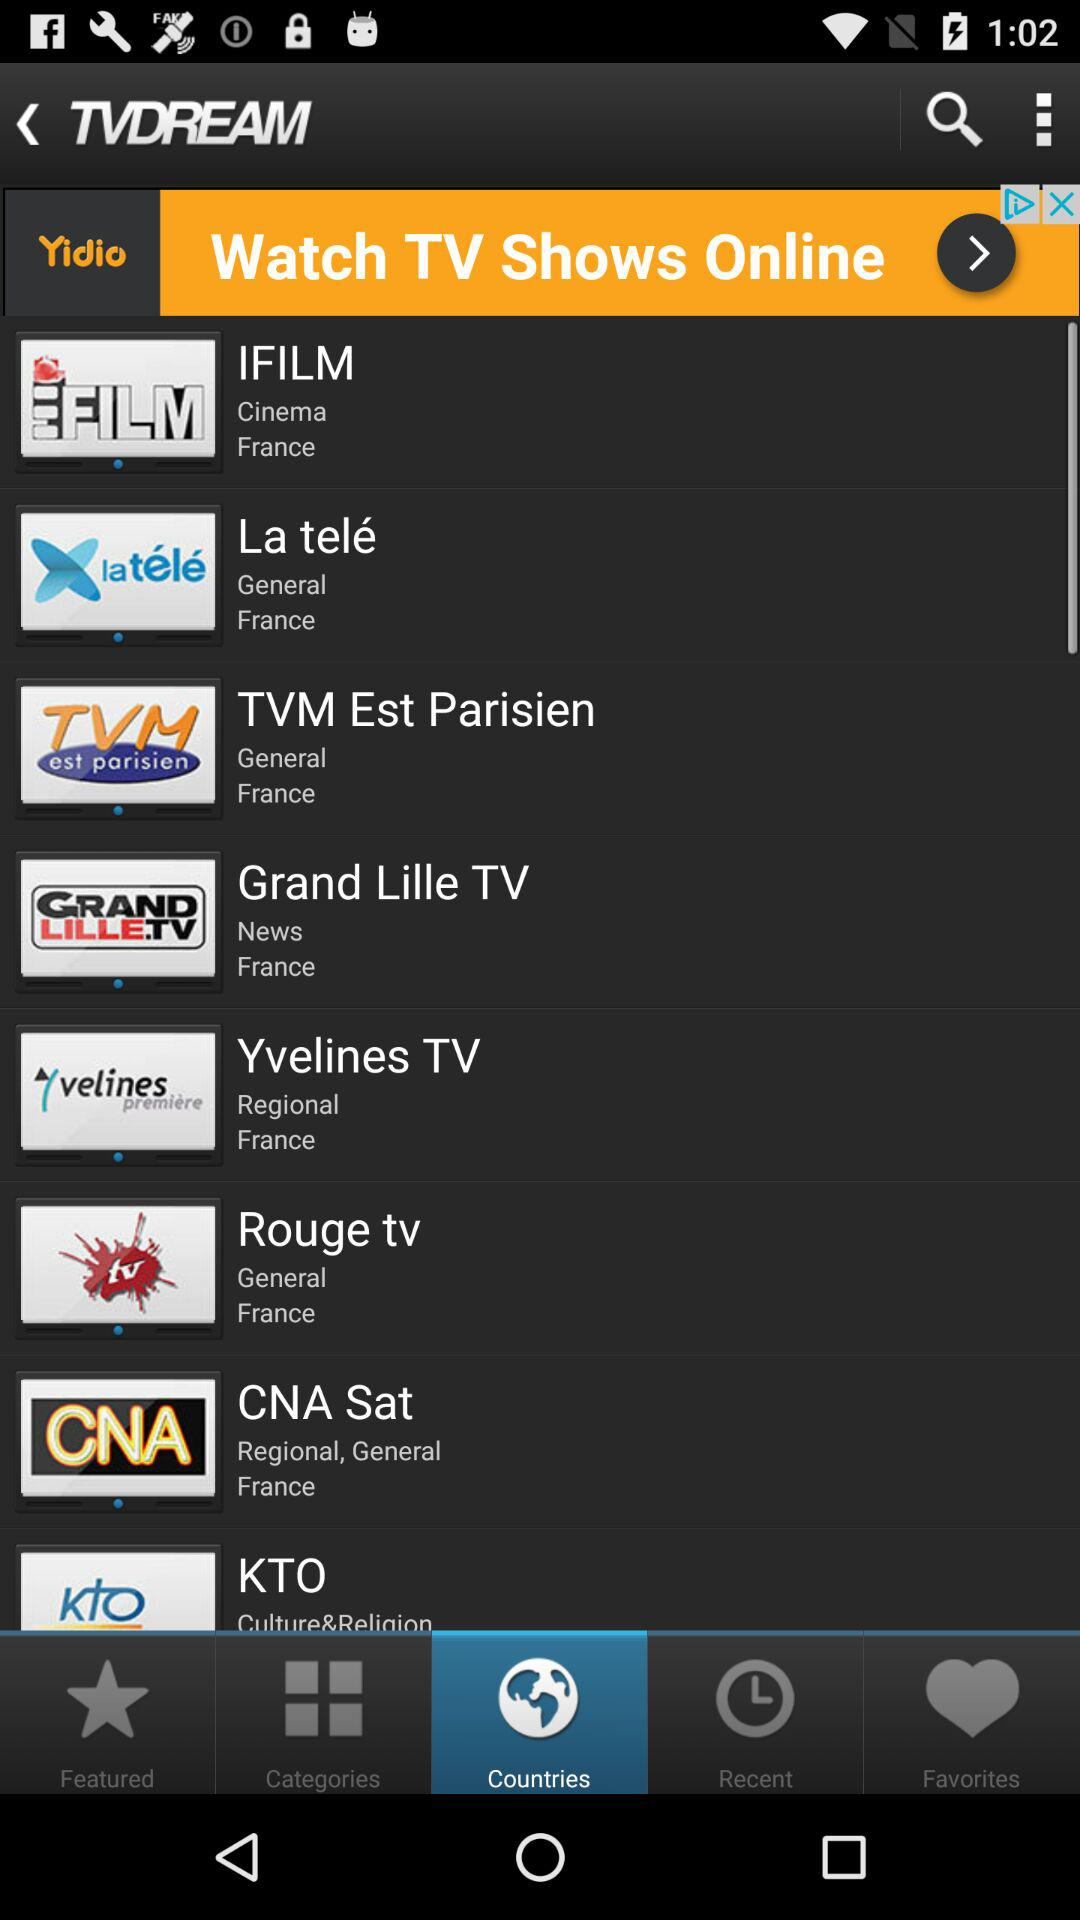What are the news channel names? The news channel name is "Grand Lille TV". 